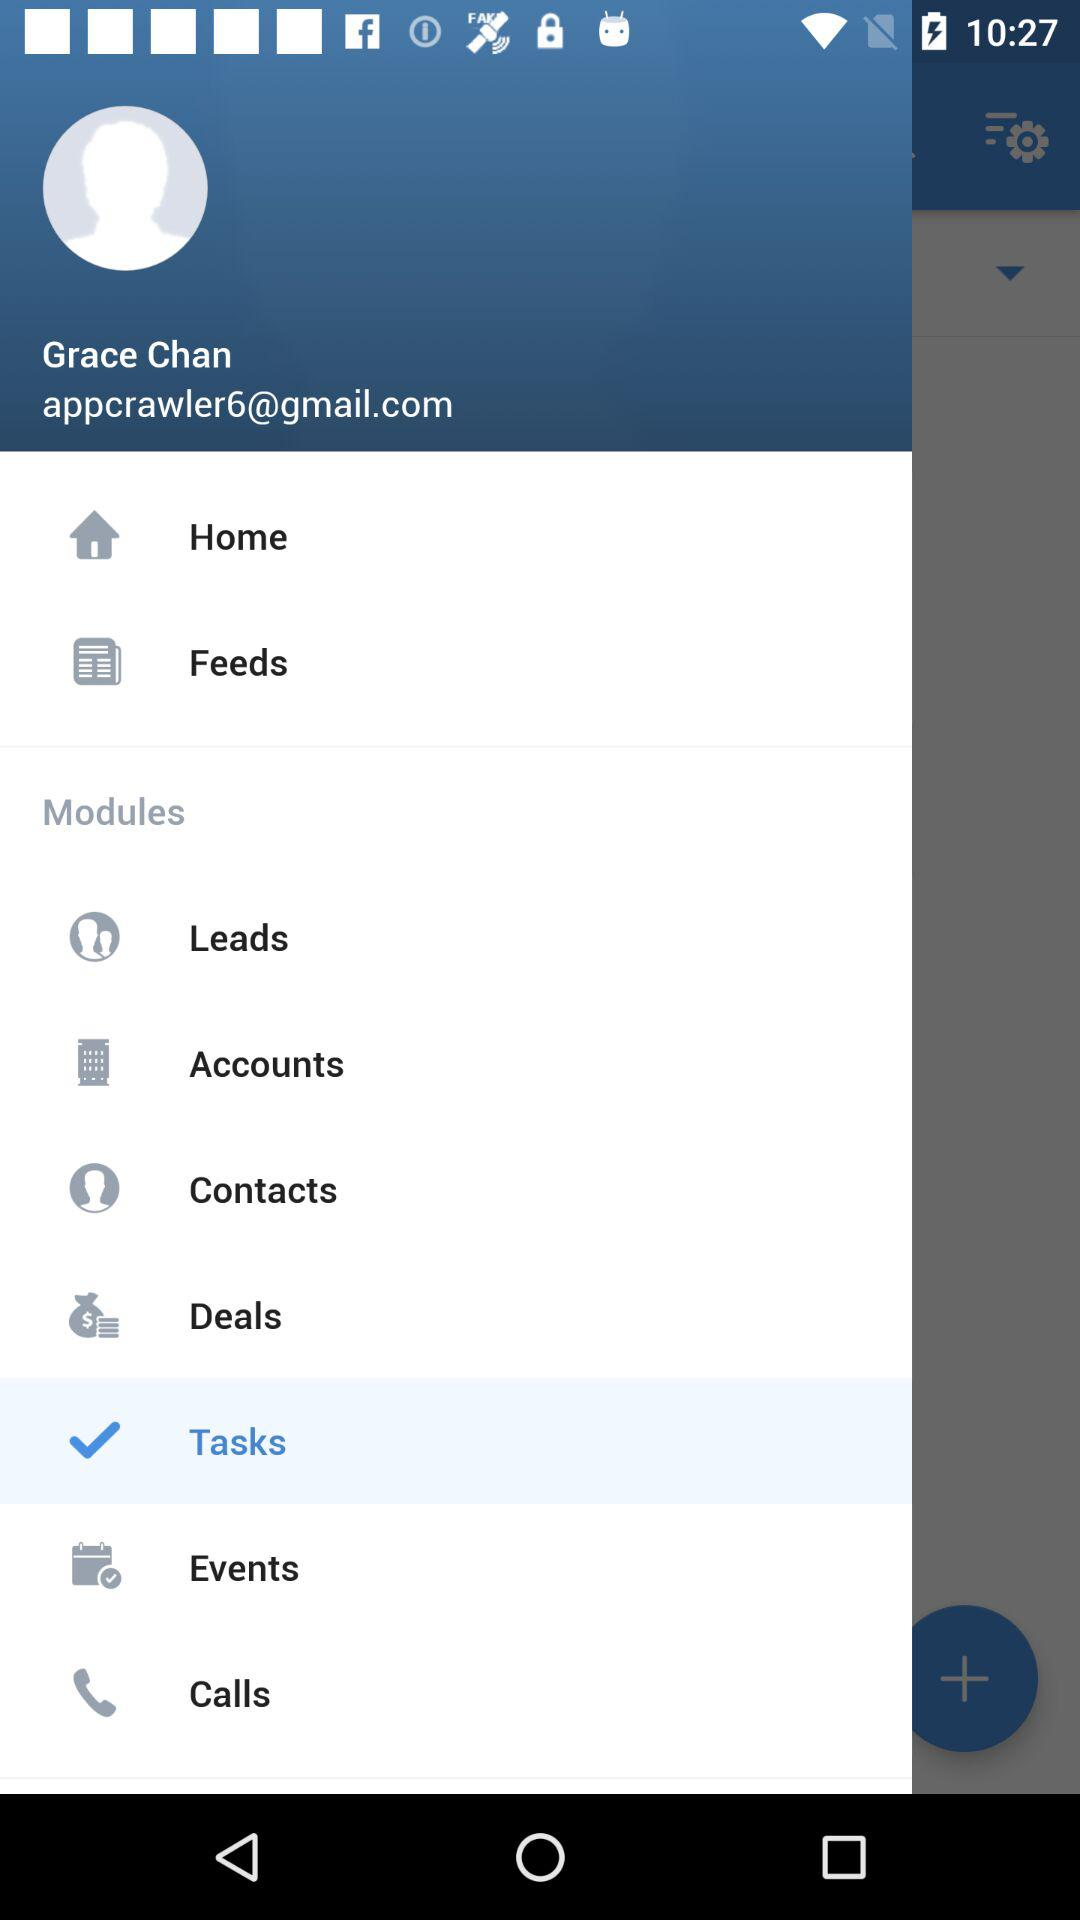Which item is selected? The selected item is "Tasks". 